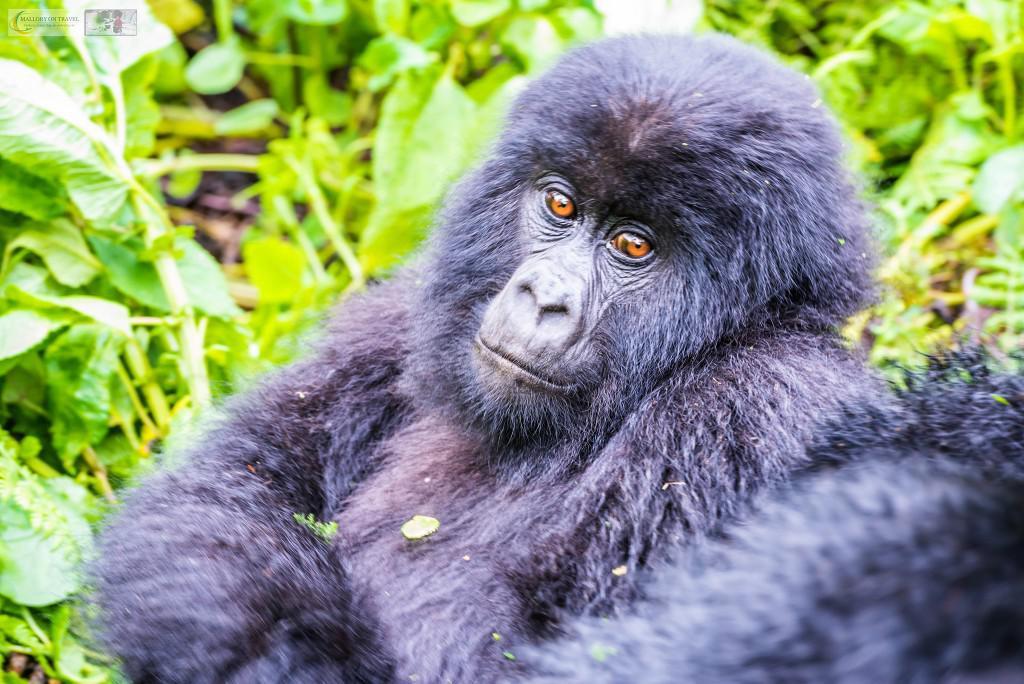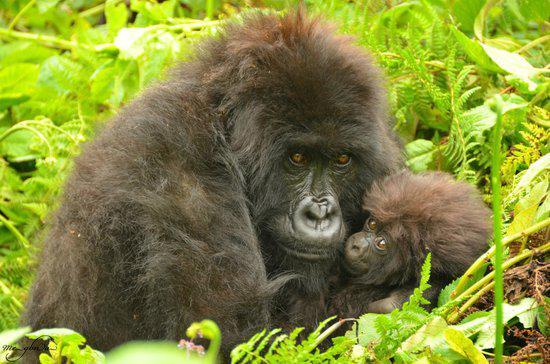The first image is the image on the left, the second image is the image on the right. Examine the images to the left and right. Is the description "A single primate is in the grass in each of the images." accurate? Answer yes or no. No. 